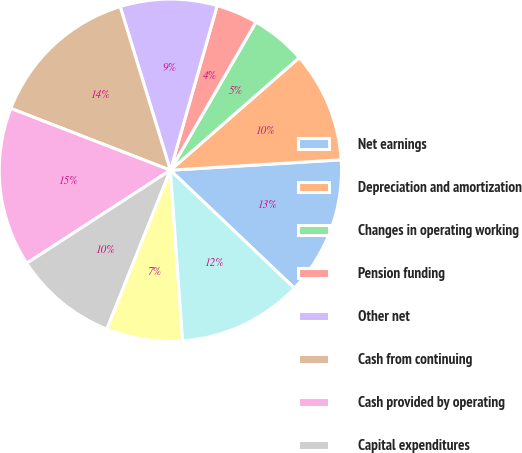Convert chart. <chart><loc_0><loc_0><loc_500><loc_500><pie_chart><fcel>Net earnings<fcel>Depreciation and amortization<fcel>Changes in operating working<fcel>Pension funding<fcel>Other net<fcel>Cash from continuing<fcel>Cash provided by operating<fcel>Capital expenditures<fcel>Purchases of businesses net of<fcel>Cash provided by (used in)<nl><fcel>13.07%<fcel>10.46%<fcel>5.23%<fcel>3.93%<fcel>9.15%<fcel>14.38%<fcel>15.03%<fcel>9.8%<fcel>7.19%<fcel>11.76%<nl></chart> 